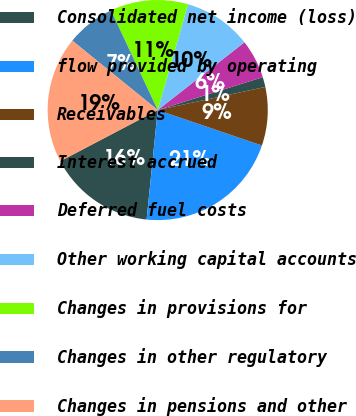Convert chart to OTSL. <chart><loc_0><loc_0><loc_500><loc_500><pie_chart><fcel>Consolidated net income (loss)<fcel>flow provided by operating<fcel>Receivables<fcel>Interest accrued<fcel>Deferred fuel costs<fcel>Other working capital accounts<fcel>Changes in provisions for<fcel>Changes in other regulatory<fcel>Changes in pensions and other<nl><fcel>15.7%<fcel>21.39%<fcel>8.58%<fcel>1.46%<fcel>5.73%<fcel>10.0%<fcel>11.43%<fcel>7.16%<fcel>18.55%<nl></chart> 